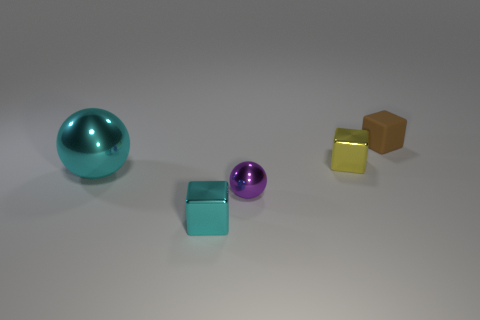There is a purple object that is the same size as the yellow metal block; what is it made of?
Provide a succinct answer. Metal. There is a matte cube; is its size the same as the shiny block on the right side of the small cyan metallic thing?
Provide a succinct answer. Yes. What number of cyan metal spheres are the same size as the cyan shiny cube?
Give a very brief answer. 0. The other small block that is made of the same material as the tiny yellow cube is what color?
Offer a terse response. Cyan. Are there more large cyan spheres than tiny green balls?
Provide a short and direct response. Yes. Is the material of the brown block the same as the large cyan ball?
Give a very brief answer. No. There is a small yellow thing that is the same material as the purple object; what is its shape?
Ensure brevity in your answer.  Cube. Is the number of balls less than the number of tiny metal balls?
Keep it short and to the point. No. What material is the tiny object that is behind the cyan block and on the left side of the small yellow thing?
Ensure brevity in your answer.  Metal. How big is the block that is to the left of the shiny block to the right of the small cube that is in front of the big thing?
Provide a succinct answer. Small. 